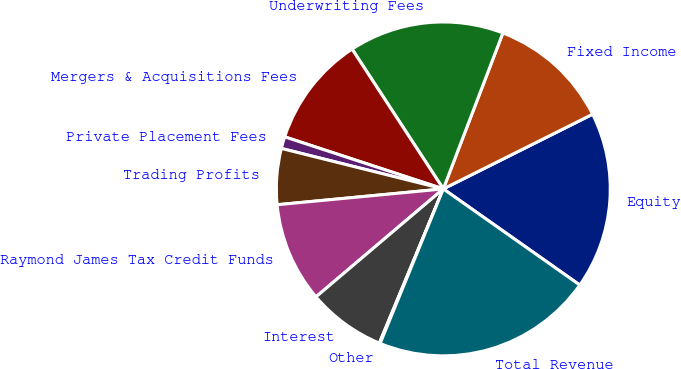Convert chart. <chart><loc_0><loc_0><loc_500><loc_500><pie_chart><fcel>Equity<fcel>Fixed Income<fcel>Underwriting Fees<fcel>Mergers & Acquisitions Fees<fcel>Private Placement Fees<fcel>Trading Profits<fcel>Raymond James Tax Credit Funds<fcel>Interest<fcel>Other<fcel>Total Revenue<nl><fcel>17.15%<fcel>11.81%<fcel>15.01%<fcel>10.75%<fcel>1.15%<fcel>5.41%<fcel>9.68%<fcel>7.55%<fcel>0.08%<fcel>21.41%<nl></chart> 